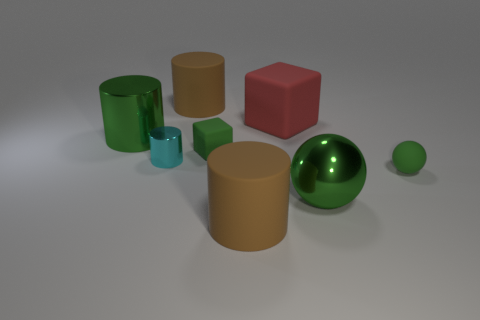Add 1 large brown cylinders. How many objects exist? 9 Subtract all blocks. How many objects are left? 6 Add 1 green metallic things. How many green metallic things exist? 3 Subtract 0 brown cubes. How many objects are left? 8 Subtract all tiny cyan rubber blocks. Subtract all rubber things. How many objects are left? 3 Add 2 rubber cubes. How many rubber cubes are left? 4 